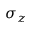Convert formula to latex. <formula><loc_0><loc_0><loc_500><loc_500>\sigma _ { z }</formula> 